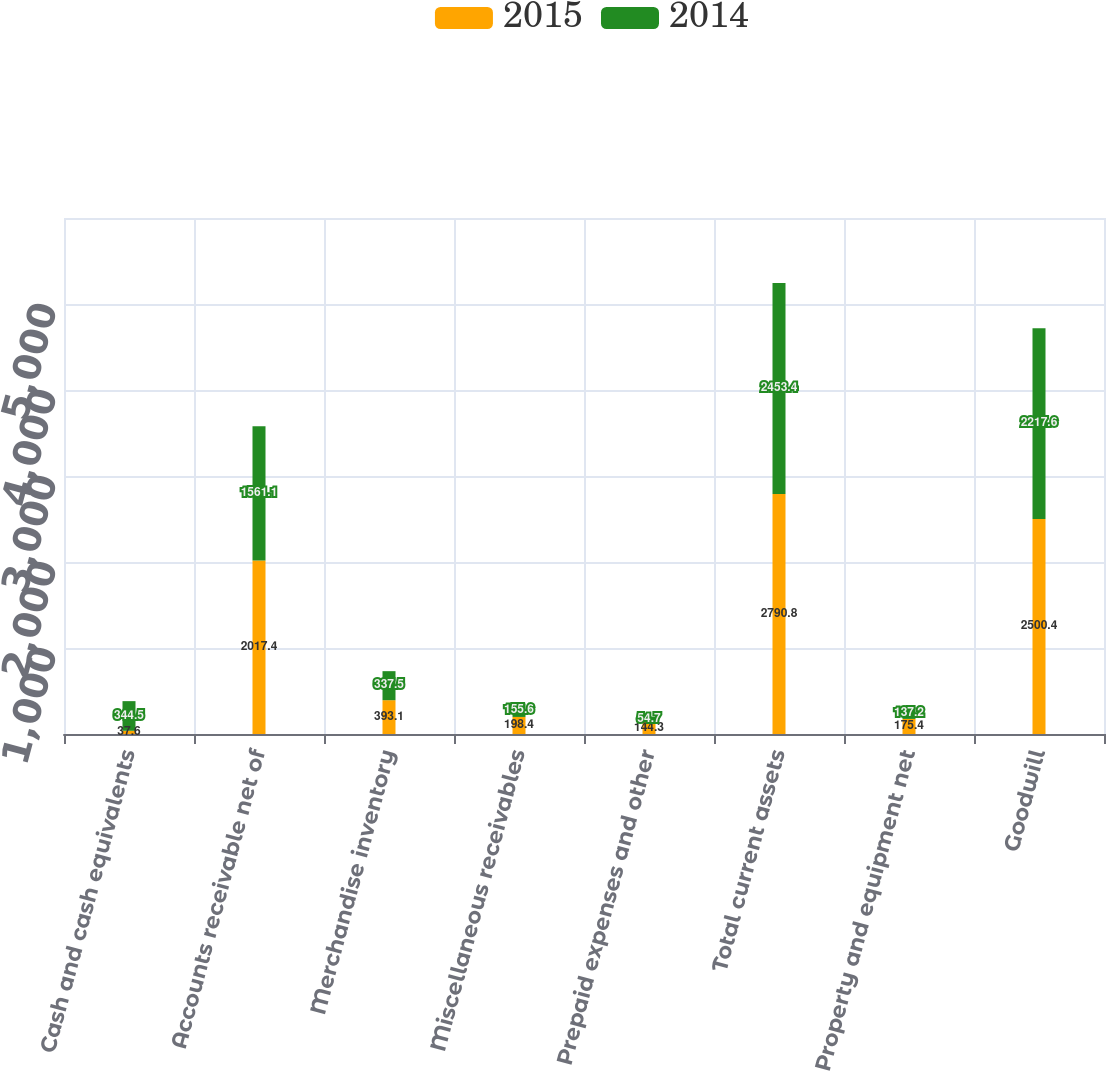Convert chart. <chart><loc_0><loc_0><loc_500><loc_500><stacked_bar_chart><ecel><fcel>Cash and cash equivalents<fcel>Accounts receivable net of<fcel>Merchandise inventory<fcel>Miscellaneous receivables<fcel>Prepaid expenses and other<fcel>Total current assets<fcel>Property and equipment net<fcel>Goodwill<nl><fcel>2015<fcel>37.6<fcel>2017.4<fcel>393.1<fcel>198.4<fcel>144.3<fcel>2790.8<fcel>175.4<fcel>2500.4<nl><fcel>2014<fcel>344.5<fcel>1561.1<fcel>337.5<fcel>155.6<fcel>54.7<fcel>2453.4<fcel>137.2<fcel>2217.6<nl></chart> 